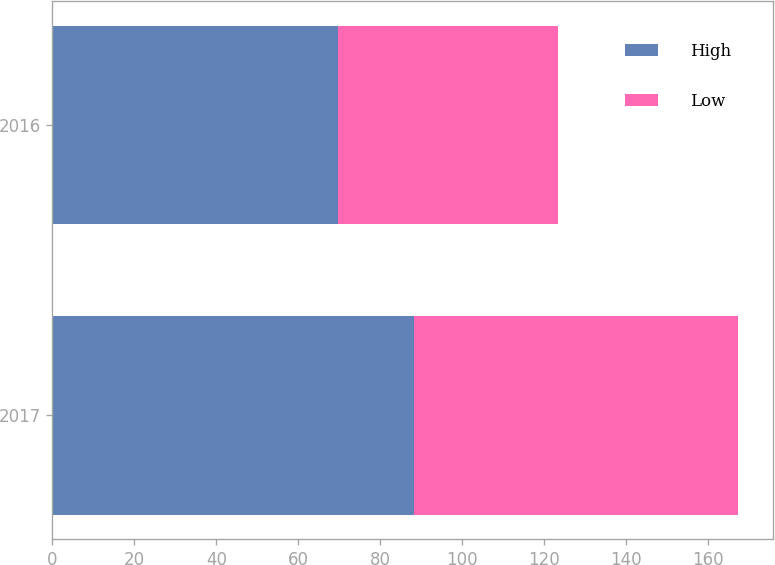Convert chart to OTSL. <chart><loc_0><loc_0><loc_500><loc_500><stacked_bar_chart><ecel><fcel>2017<fcel>2016<nl><fcel>High<fcel>88.3<fcel>69.59<nl><fcel>Low<fcel>79.06<fcel>53.88<nl></chart> 